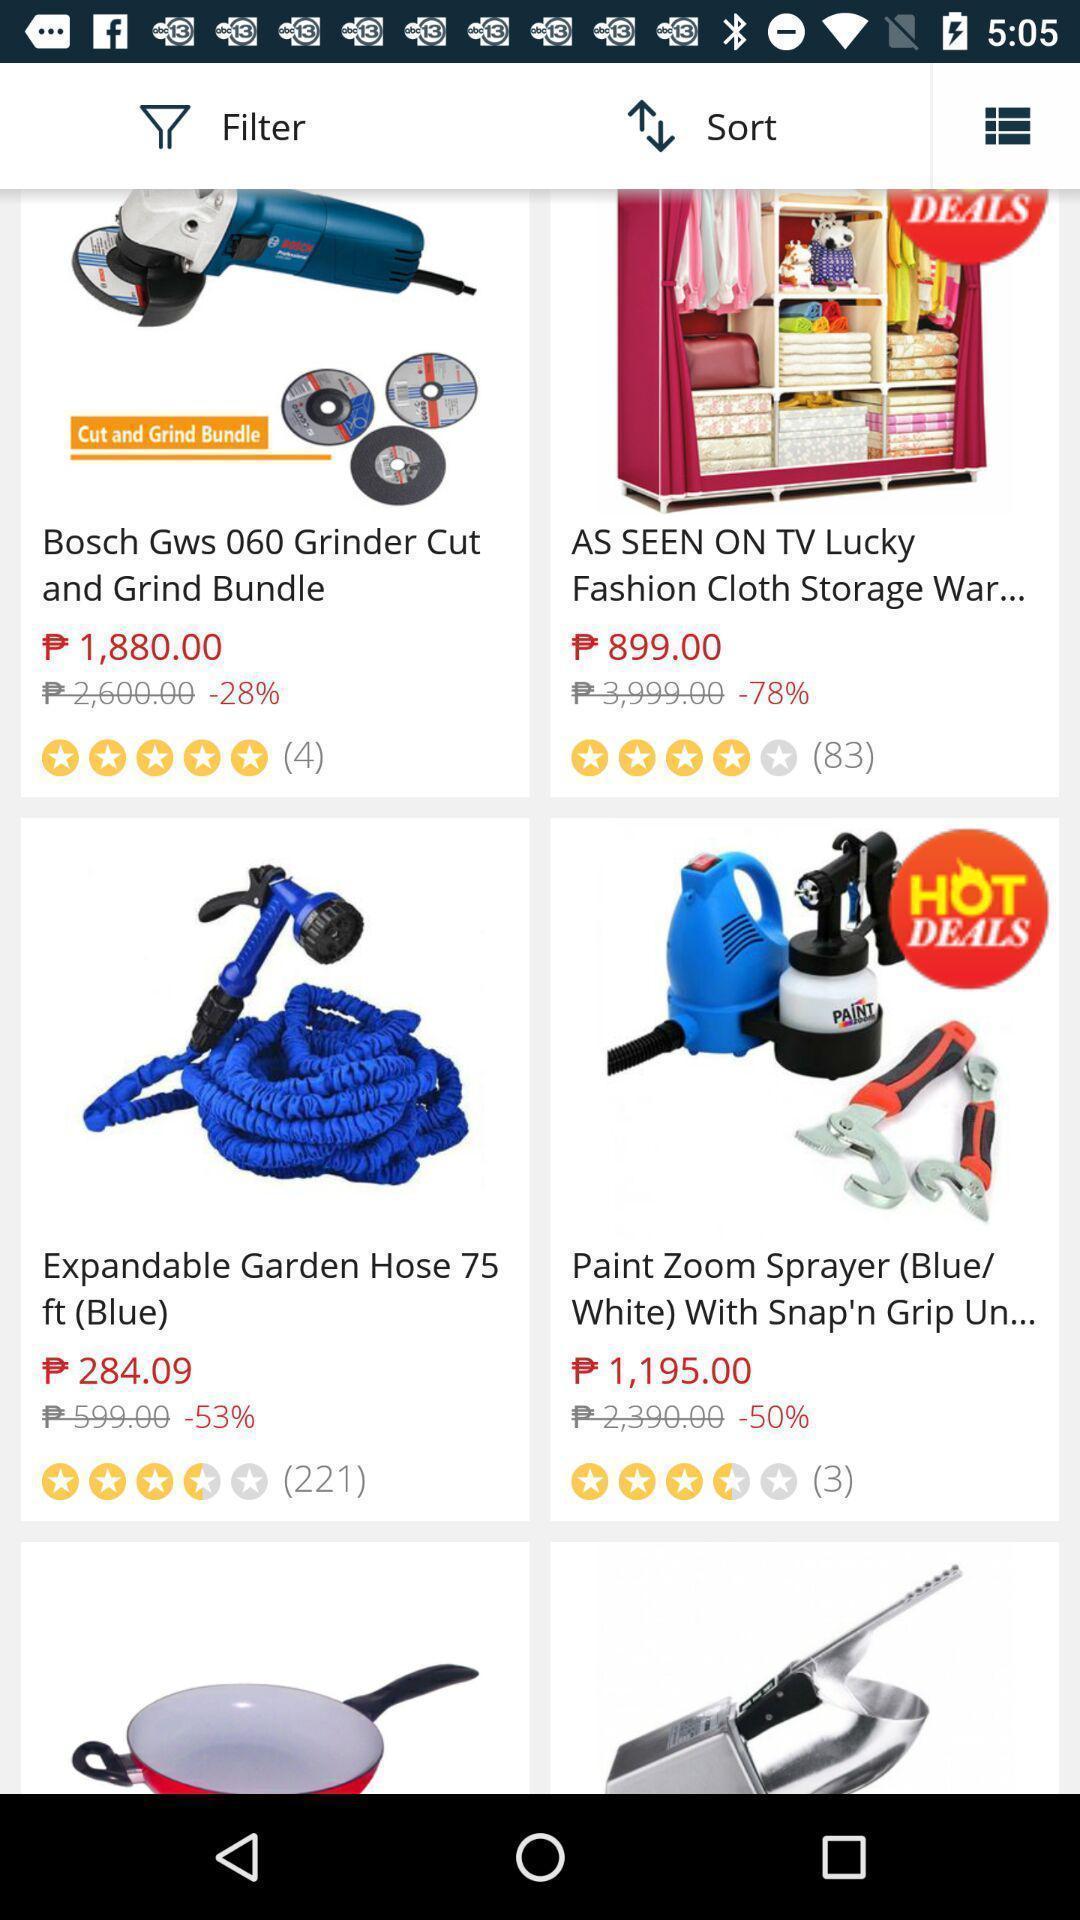Provide a description of this screenshot. Page displaying products. 